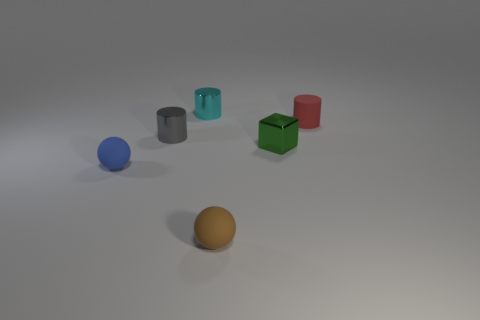Are there any other objects that have the same size as the red matte thing?
Your answer should be compact. Yes. What number of objects are either big blue rubber spheres or small matte objects?
Give a very brief answer. 3. Are there any small purple things of the same shape as the cyan object?
Ensure brevity in your answer.  No. Are there fewer rubber cylinders in front of the red object than tiny gray metal objects?
Provide a short and direct response. Yes. Do the small green metal thing and the brown matte object have the same shape?
Your answer should be very brief. No. Is the number of big rubber cylinders less than the number of tiny green metal cubes?
Offer a very short reply. Yes. What material is the cyan cylinder that is the same size as the gray shiny object?
Provide a short and direct response. Metal. Is the number of small metal objects greater than the number of tiny blue blocks?
Your answer should be very brief. Yes. How many small rubber objects are behind the tiny brown matte sphere and right of the gray metal thing?
Provide a short and direct response. 1. Are there more small red cylinders that are to the right of the small brown rubber sphere than tiny brown rubber things behind the tiny blue matte object?
Make the answer very short. Yes. 